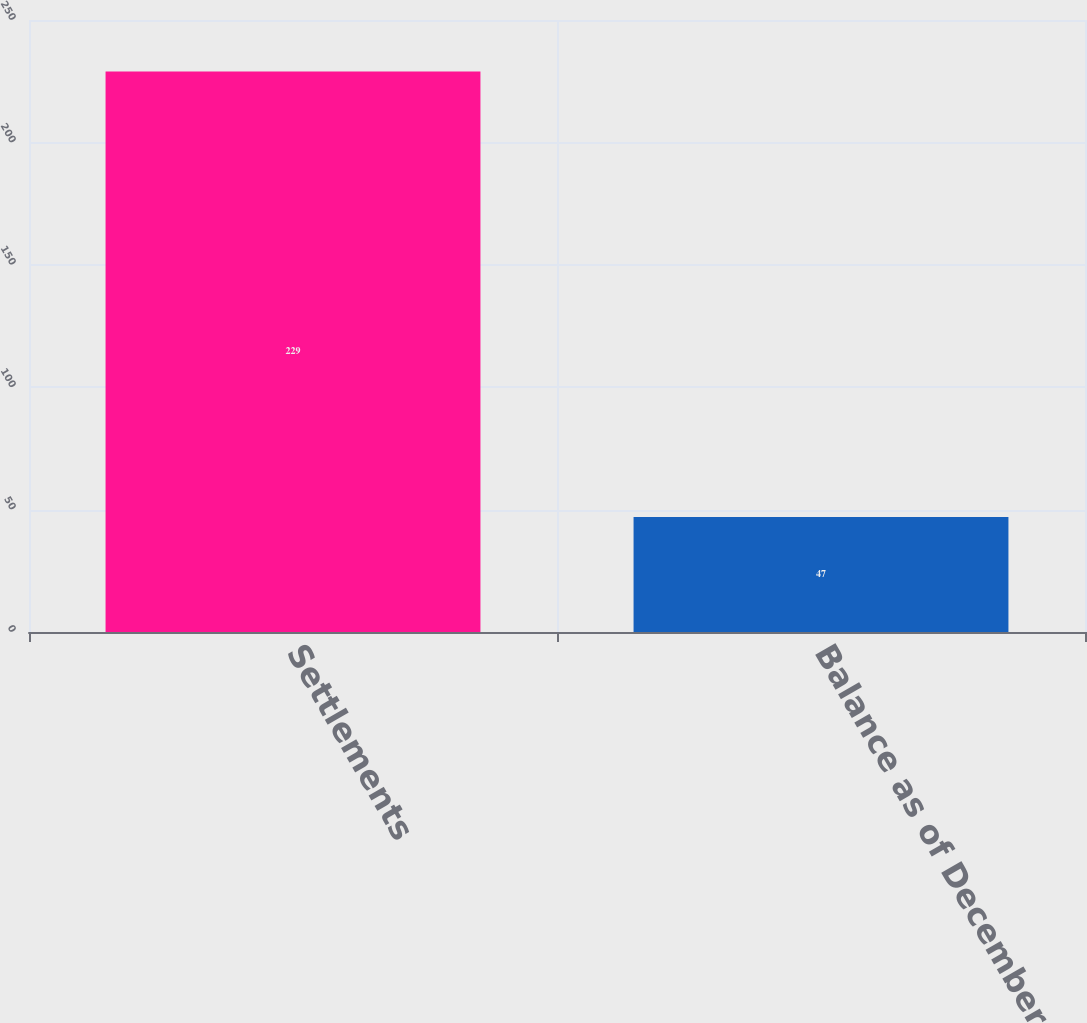Convert chart. <chart><loc_0><loc_0><loc_500><loc_500><bar_chart><fcel>Settlements<fcel>Balance as of December 31<nl><fcel>229<fcel>47<nl></chart> 